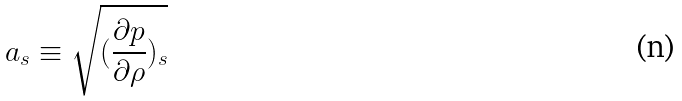Convert formula to latex. <formula><loc_0><loc_0><loc_500><loc_500>a _ { s } \equiv \sqrt { ( \frac { \partial p } { \partial \rho } ) _ { s } }</formula> 